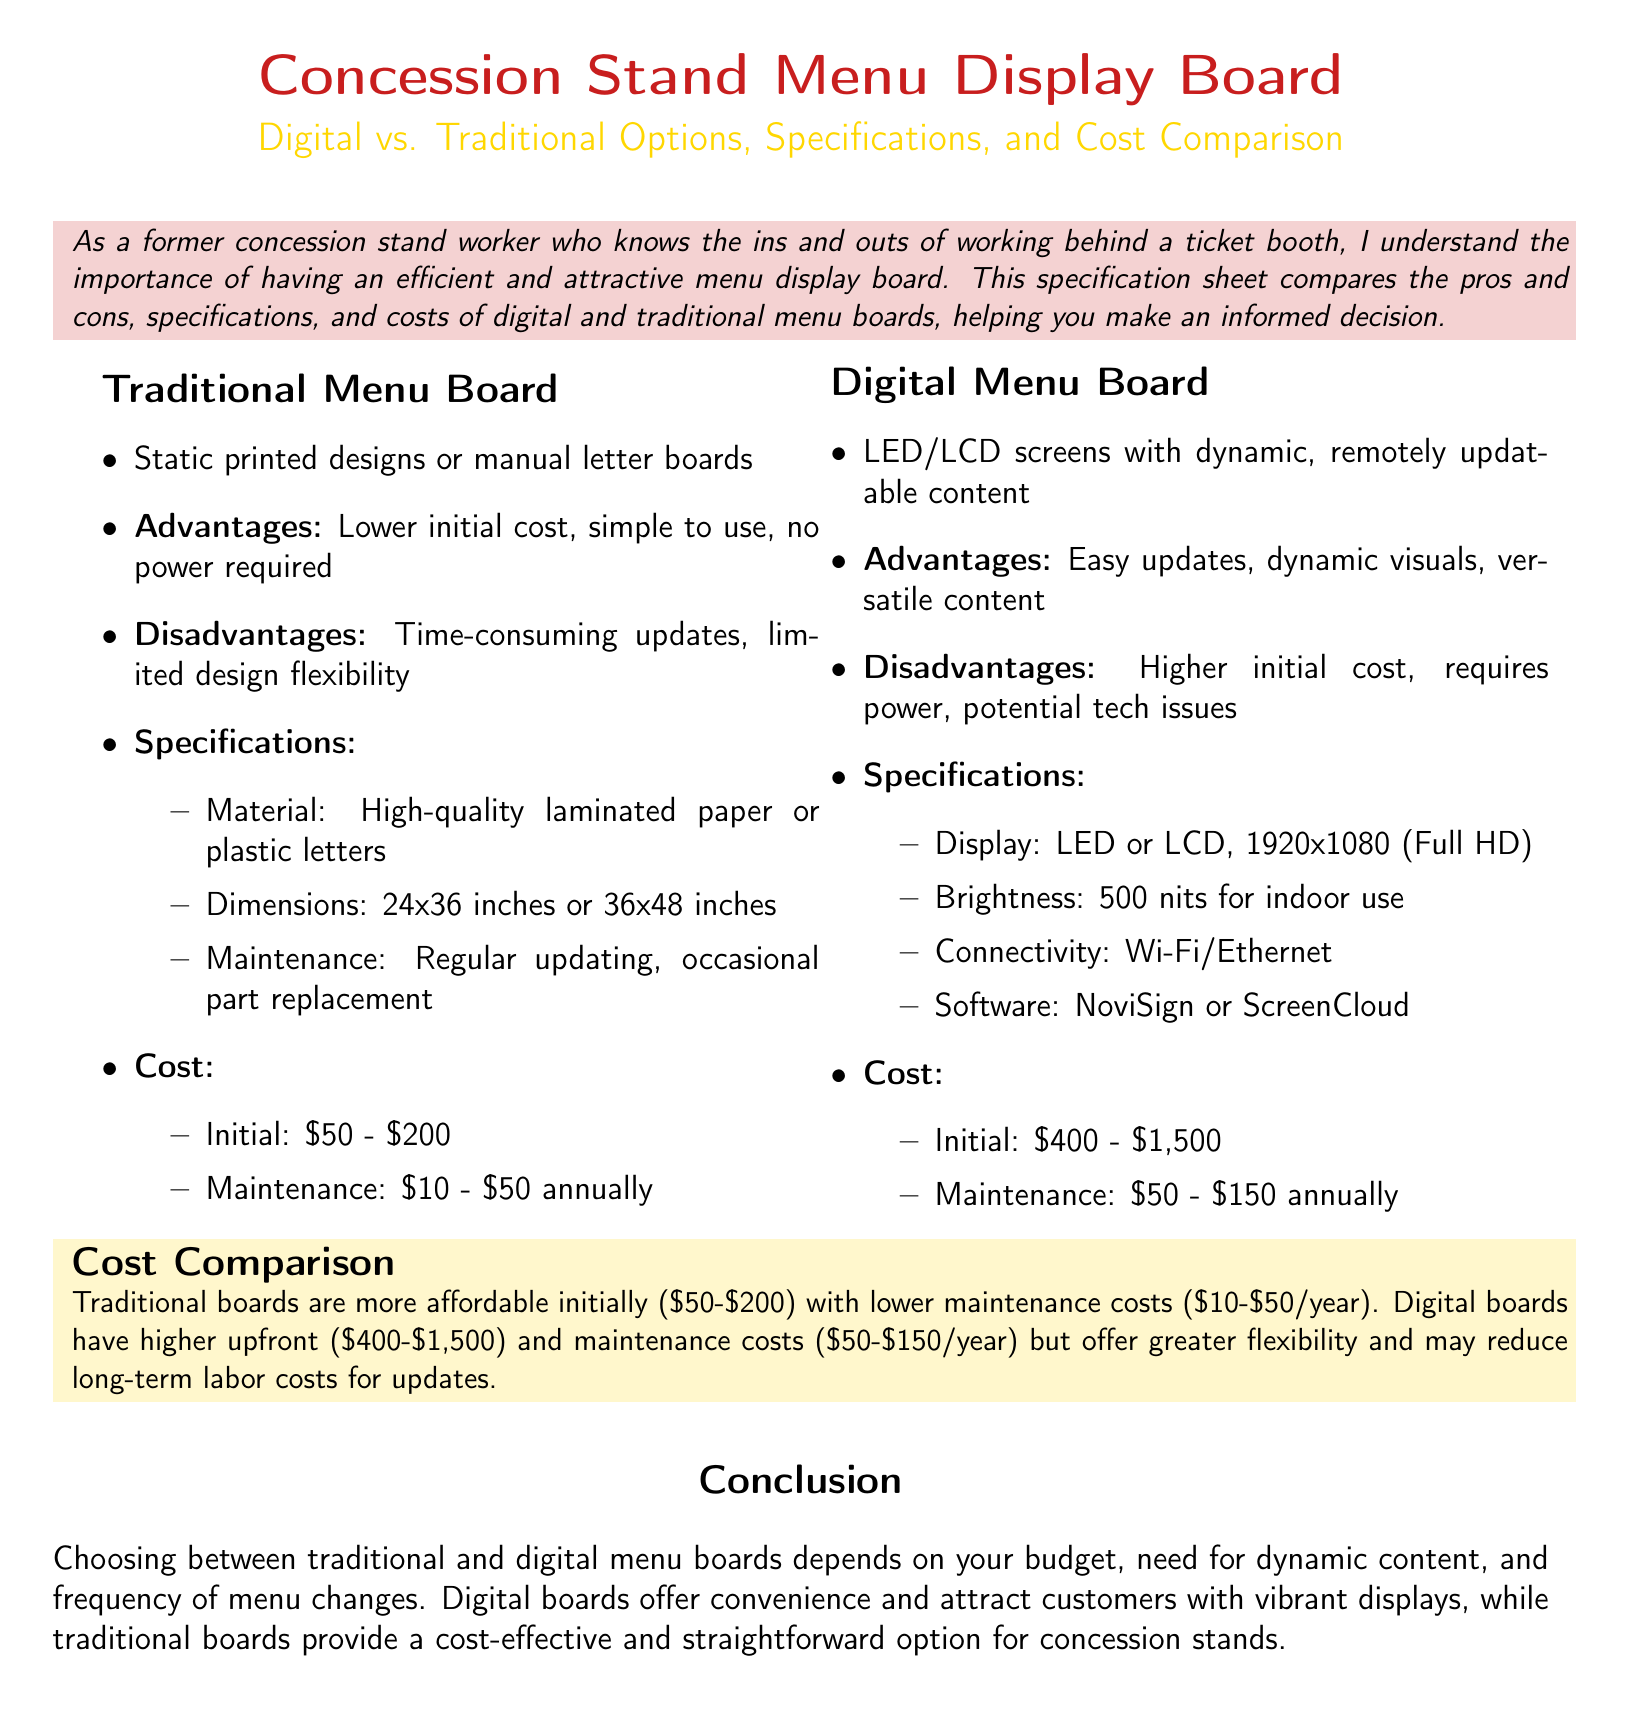What is a primary advantage of traditional menu boards? Traditional menu boards have a lower initial cost and are simple to use, making them a primary advantage.
Answer: Lower initial cost What is the maintenance cost for digital menu boards annually? The document specifies that the maintenance cost for digital menu boards ranges from $50 to $150 annually.
Answer: $50 - $150 What display resolution do digital menu boards have? According to the specifications for digital menu boards, they feature a display of 1920x1080 (Full HD).
Answer: 1920x1080 What is one disadvantage of a digital menu board? One of the disadvantages listed for digital menu boards is that they may face potential tech issues, emphasizing the reliability concern.
Answer: Potential tech issues How much can a traditional menu board cost initially? The document states that the initial cost for traditional menu boards ranges from $50 to $200.
Answer: $50 - $200 What material is used for traditional menu boards? The specifications indicate that traditional menu boards are made from high-quality laminated paper or plastic letters.
Answer: High-quality laminated paper or plastic letters What is the brightness of digital menu boards for indoor use? The document specifies that digital menu boards have a brightness of 500 nits for indoor use, which affects visibility.
Answer: 500 nits Which type of menu board offers dynamic visuals? The document states that digital menu boards offer dynamic visuals, highlighting their ability to change content easily.
Answer: Digital menu boards What is the cost difference between the initial expense of traditional and digital menu boards? The document compares the initial costs, showing that traditional menu boards are generally more affordable than digital ones, detailing a difference of $350 to $1,300.
Answer: $350 - $1,300 